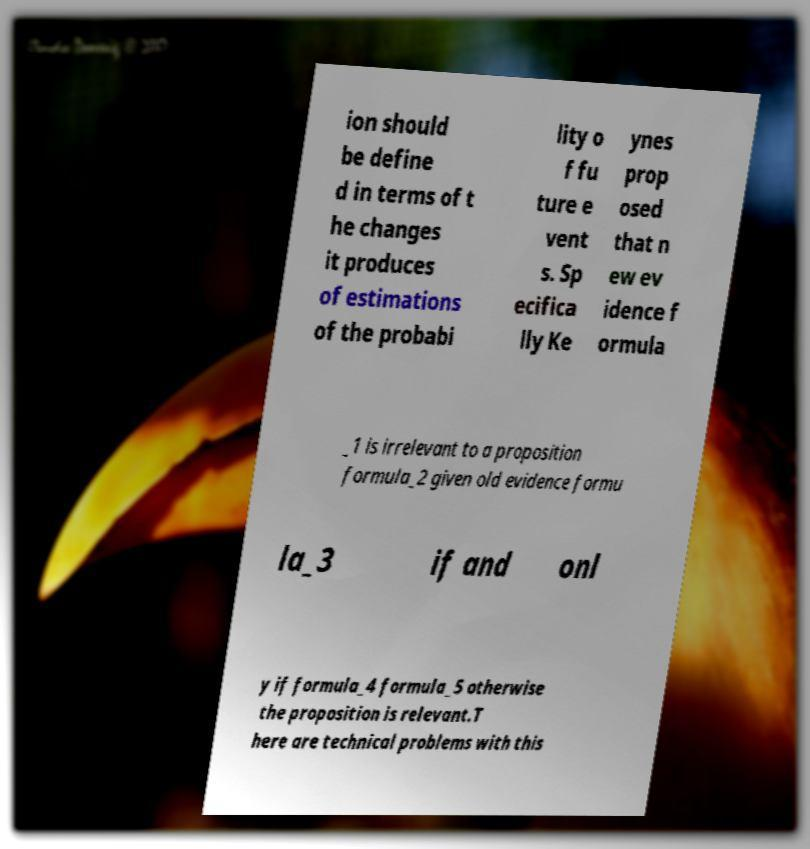Could you extract and type out the text from this image? ion should be define d in terms of t he changes it produces of estimations of the probabi lity o f fu ture e vent s. Sp ecifica lly Ke ynes prop osed that n ew ev idence f ormula _1 is irrelevant to a proposition formula_2 given old evidence formu la_3 if and onl y if formula_4 formula_5 otherwise the proposition is relevant.T here are technical problems with this 